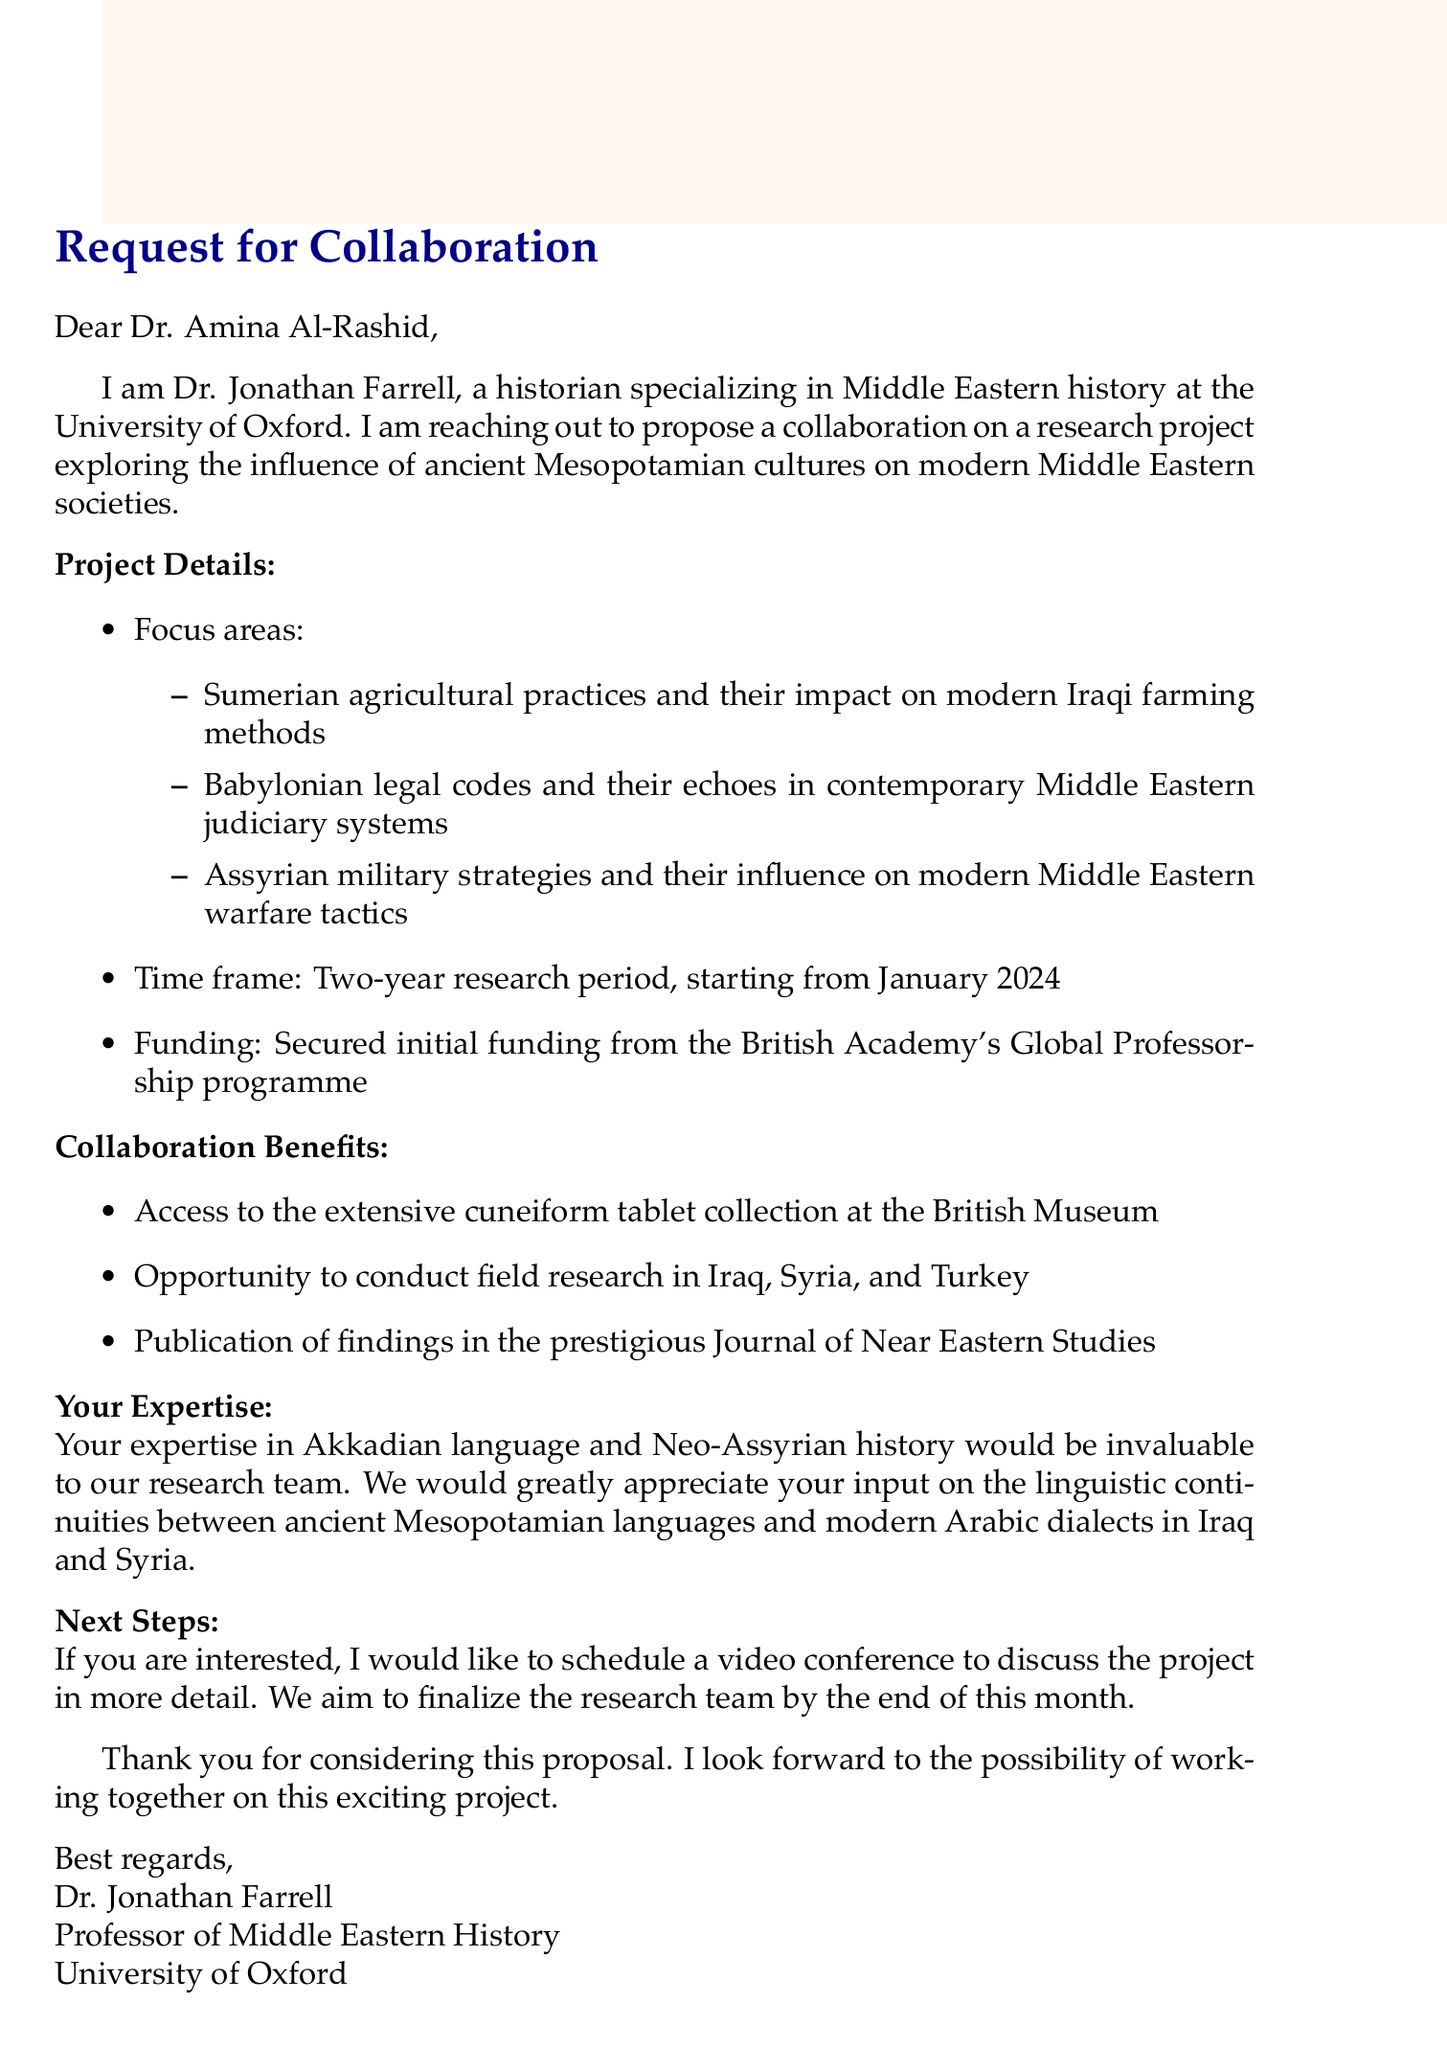What is the name of the sender? The sender of the email is introduced as Dr. Jonathan Farrell, a historian specializing in Middle Eastern history.
Answer: Dr. Jonathan Farrell What is the focus area related to agricultural practices? One of the focus areas mentioned is the influence of Sumerian agricultural practices on modern Iraqi farming methods.
Answer: Sumerian agricultural practices What is the duration of the proposed research project? The document states that the proposed research period is for two years.
Answer: Two years In which month does the proposed research project start? The starting month for the research project is specified as January 2024.
Answer: January 2024 What institution has provided initial funding for the project? The email notes that initial funding has been secured from the British Academy's Global Professorship programme.
Answer: British Academy's Global Professorship programme What specific expertise does the sender seek from Dr. Amina Al-Rashid? The sender values Dr. Amina Al-Rashid's expertise in Akkadian language and Neo-Assyrian history.
Answer: Akkadian language and Neo-Assyrian history What is one of the collaboration benefits mentioned in the email? The email lists access to the extensive cuneiform tablet collection at the British Museum as a benefit of collaboration.
Answer: Cuneiform tablet collection at the British Museum When does the sender aim to finalize the research team? The email indicates that the sender aims to finalize the research team by the end of the month.
Answer: End of this month What is the desired method for discussing the project further? The sender expresses a desire to schedule a video conference to discuss the project in more detail.
Answer: Video conference 